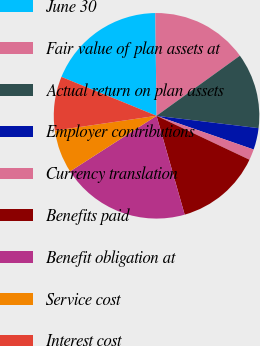Convert chart to OTSL. <chart><loc_0><loc_0><loc_500><loc_500><pie_chart><fcel>June 30<fcel>Fair value of plan assets at<fcel>Actual return on plan assets<fcel>Employer contributions<fcel>Currency translation<fcel>Benefits paid<fcel>Benefit obligation at<fcel>Service cost<fcel>Interest cost<nl><fcel>18.63%<fcel>15.25%<fcel>11.86%<fcel>3.4%<fcel>1.71%<fcel>13.56%<fcel>20.32%<fcel>6.79%<fcel>8.48%<nl></chart> 